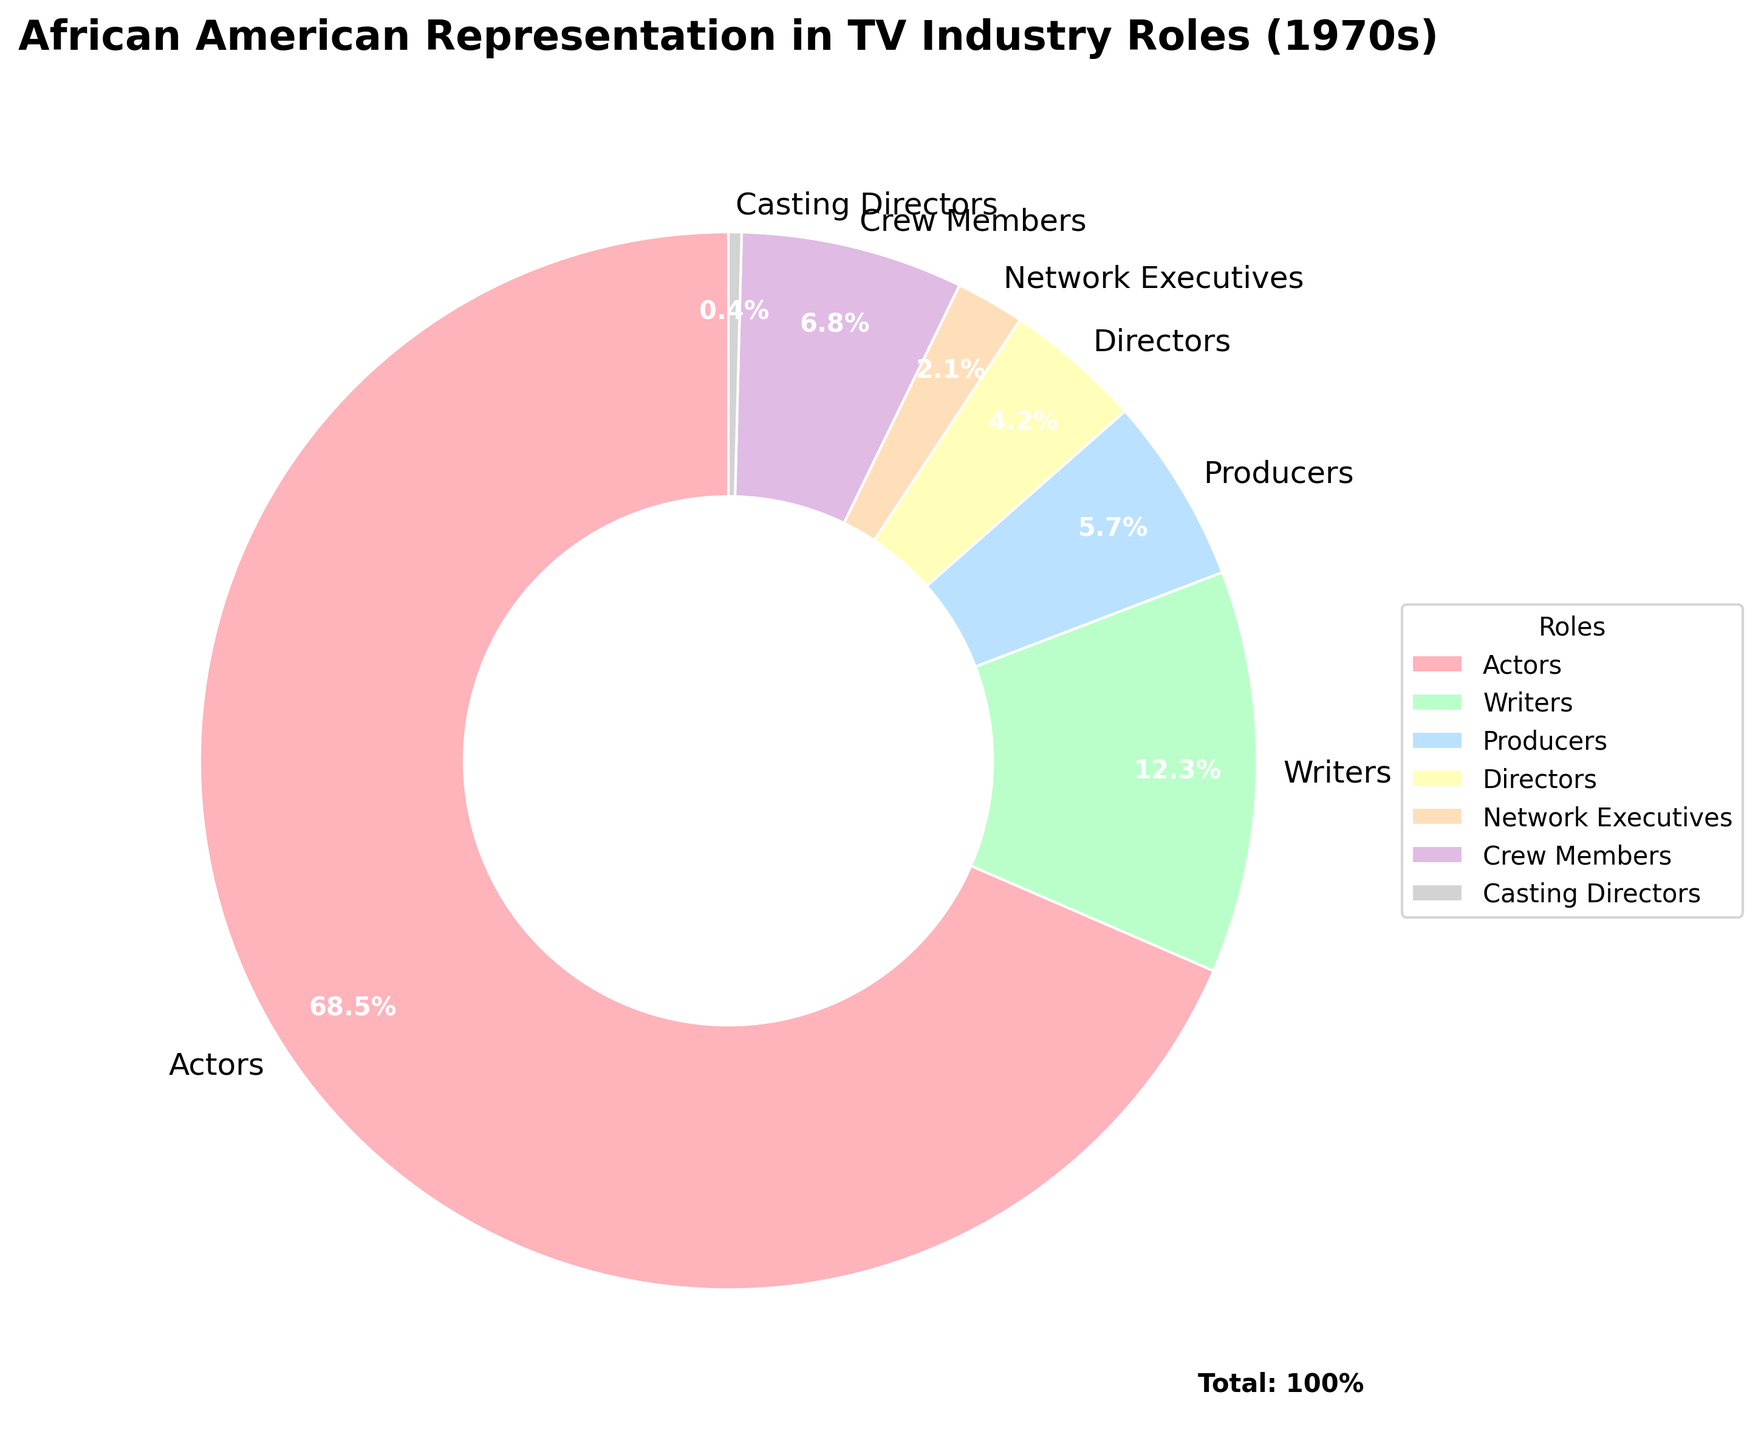Which role has the highest percentage of African American representation in the TV industry in the 1970s? The pie chart shows different roles with percentages. The Actors segment has the largest portion, indicating 68.5%.
Answer: Actors What is the combined percentage of African Americans in Writers and Producers roles? The percentages for Writers and Producers are given as 12.3% and 5.7% respectively. Adding these together: 12.3% + 5.7% = 18.0%.
Answer: 18.0% Which role has the smallest representation according to the chart? The pie chart shows percentages for each role. The smallest value is 0.4%, which corresponds to Casting Directors.
Answer: Casting Directors How does the percentage of African American Crew Members compare to that of Network Executives? The pie chart indicates that Crew Members hold 6.8% while Network Executives hold 2.1%. Since 6.8% is greater than 2.1%, Crew Members have a higher representation.
Answer: Crew Members have a higher representation What is the total representation percentage of Directors and Crew Members combined? Directors have 4.2% and Crew Members have 6.8%. Adding these together: 4.2% + 6.8% = 11.0%.
Answer: 11.0% How much higher is the percentage of African American Actors compared to Writers? The percentage for Actors is 68.5%, and for Writers, it is 12.3%. Subtract the percentage of Writers from Actors: 68.5% - 12.3% = 56.2%.
Answer: 56.2% What is the difference between the percentage of African Americans in Producers and Directors roles? The Producers hold 5.7% and Directors hold 4.2%. Subtract the percentage of Directors from Producers: 5.7% - 4.2% = 1.5%.
Answer: 1.5% Which two roles have a combined total of exactly 18% representation? By comparing the given percentages, Writers (12.3%) and Producers (5.7%) together add up to 18.0%.
Answer: Writers and Producers Does the role of Casting Directors represent more than 1% of the total? The pie chart shows that the percentage for Casting Directors is 0.4%, which is less than 1%.
Answer: No What is the average percentage representation of the actor, writer, and producer roles? The percentages for Actors, Writers, and Producers are 68.5%, 12.3%, and 5.7% respectively. The average is (68.5 + 12.3 + 5.7) / 3 = 86.5 / 3 = 28.83%.
Answer: 28.83% 